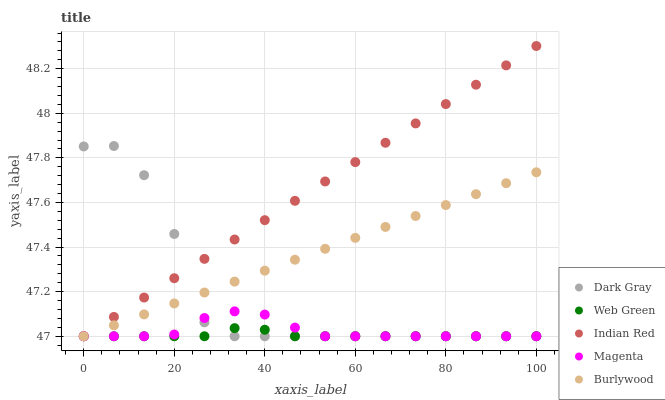Does Web Green have the minimum area under the curve?
Answer yes or no. Yes. Does Indian Red have the maximum area under the curve?
Answer yes or no. Yes. Does Burlywood have the minimum area under the curve?
Answer yes or no. No. Does Burlywood have the maximum area under the curve?
Answer yes or no. No. Is Indian Red the smoothest?
Answer yes or no. Yes. Is Dark Gray the roughest?
Answer yes or no. Yes. Is Burlywood the smoothest?
Answer yes or no. No. Is Burlywood the roughest?
Answer yes or no. No. Does Dark Gray have the lowest value?
Answer yes or no. Yes. Does Indian Red have the highest value?
Answer yes or no. Yes. Does Burlywood have the highest value?
Answer yes or no. No. Does Indian Red intersect Dark Gray?
Answer yes or no. Yes. Is Indian Red less than Dark Gray?
Answer yes or no. No. Is Indian Red greater than Dark Gray?
Answer yes or no. No. 